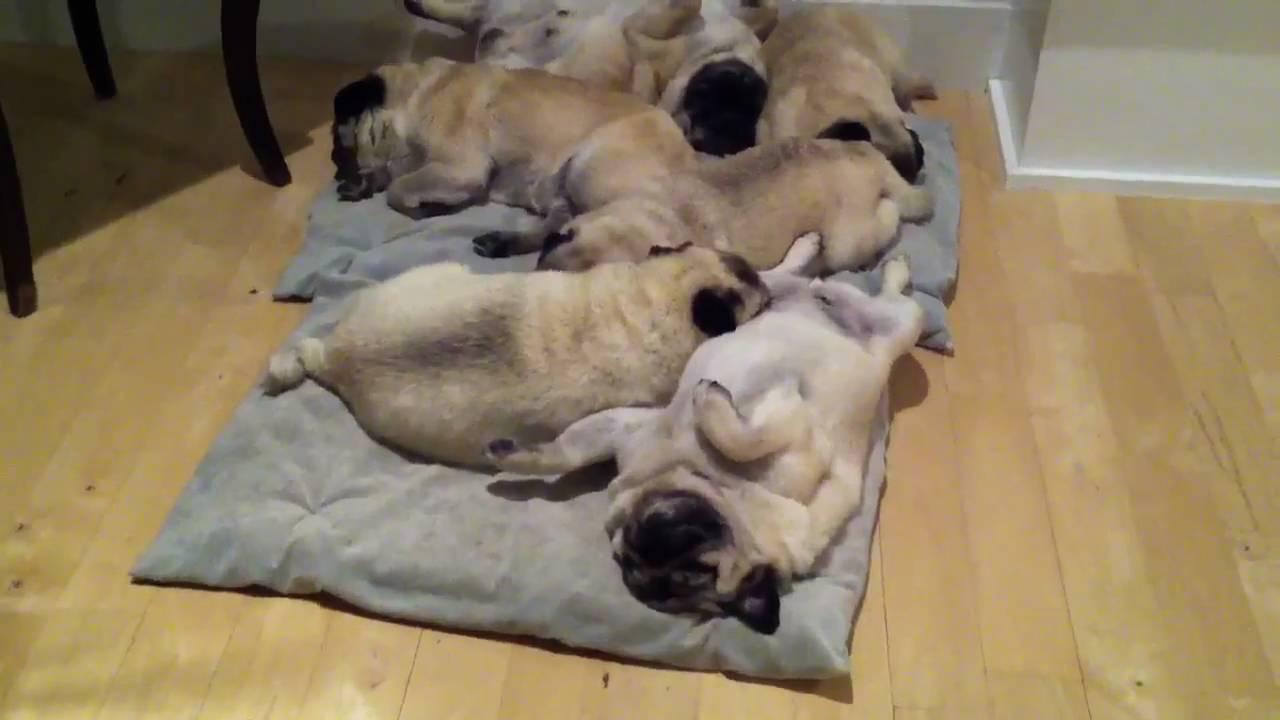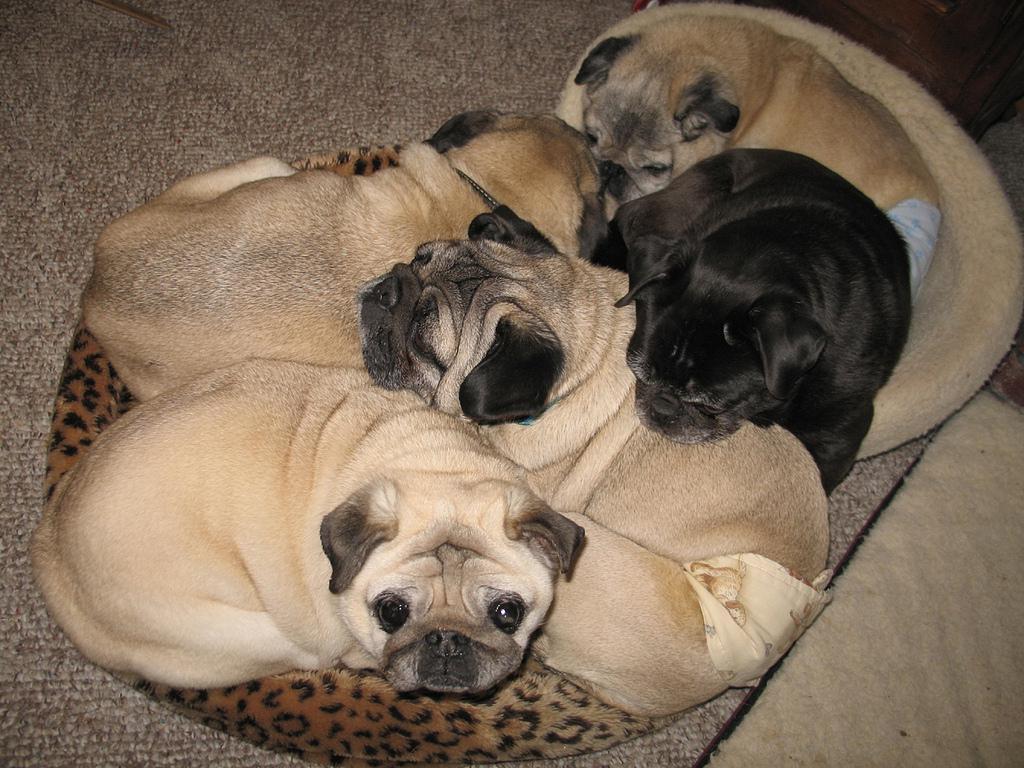The first image is the image on the left, the second image is the image on the right. Analyze the images presented: Is the assertion "There are more pug dogs in the right image than in the left." valid? Answer yes or no. No. The first image is the image on the left, the second image is the image on the right. Given the left and right images, does the statement "there are no more than three puppies in the image on the left." hold true? Answer yes or no. No. 